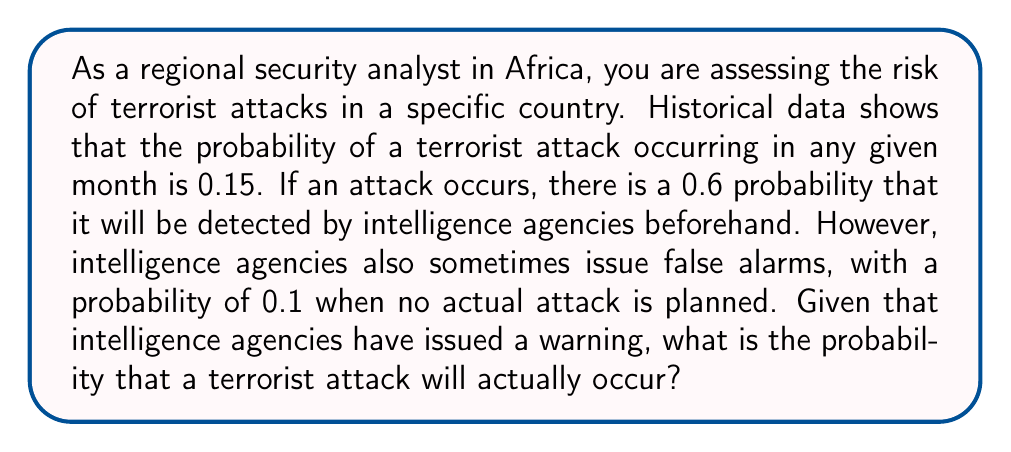Can you solve this math problem? Let's approach this problem using Bayes' theorem and conditional probability:

1. Define events:
   A: Terrorist attack occurs
   W: Warning issued by intelligence agencies

2. Given probabilities:
   P(A) = 0.15 (probability of an attack)
   P(W|A) = 0.6 (probability of a warning given an attack)
   P(W|not A) = 0.1 (probability of a warning given no attack)

3. We need to find P(A|W) using Bayes' theorem:

   $$P(A|W) = \frac{P(W|A) \cdot P(A)}{P(W)}$$

4. Calculate P(W) using the law of total probability:
   
   $$P(W) = P(W|A) \cdot P(A) + P(W|not A) \cdot P(not A)$$
   $$P(W) = 0.6 \cdot 0.15 + 0.1 \cdot (1 - 0.15)$$
   $$P(W) = 0.09 + 0.085 = 0.175$$

5. Now we can apply Bayes' theorem:

   $$P(A|W) = \frac{0.6 \cdot 0.15}{0.175} = \frac{0.09}{0.175} = 0.5142857$$

6. Convert to a percentage:
   0.5142857 * 100 ≈ 51.43%

Therefore, given that intelligence agencies have issued a warning, the probability that a terrorist attack will actually occur is approximately 51.43%.
Answer: 51.43% 